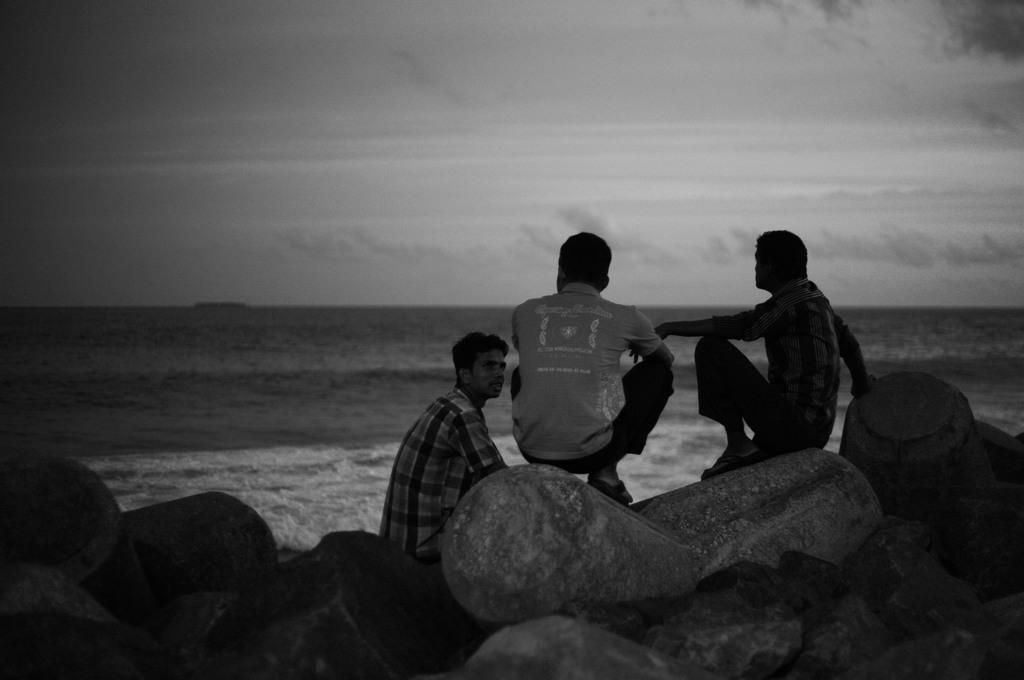Can you describe this image briefly? In this picture there are three people sitting on the rocks. At the back there is water. At the top there are clouds. 